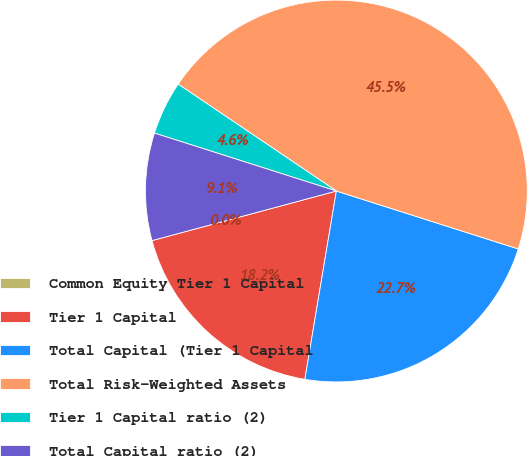<chart> <loc_0><loc_0><loc_500><loc_500><pie_chart><fcel>Common Equity Tier 1 Capital<fcel>Tier 1 Capital<fcel>Total Capital (Tier 1 Capital<fcel>Total Risk-Weighted Assets<fcel>Tier 1 Capital ratio (2)<fcel>Total Capital ratio (2)<nl><fcel>0.0%<fcel>18.18%<fcel>22.73%<fcel>45.45%<fcel>4.55%<fcel>9.09%<nl></chart> 